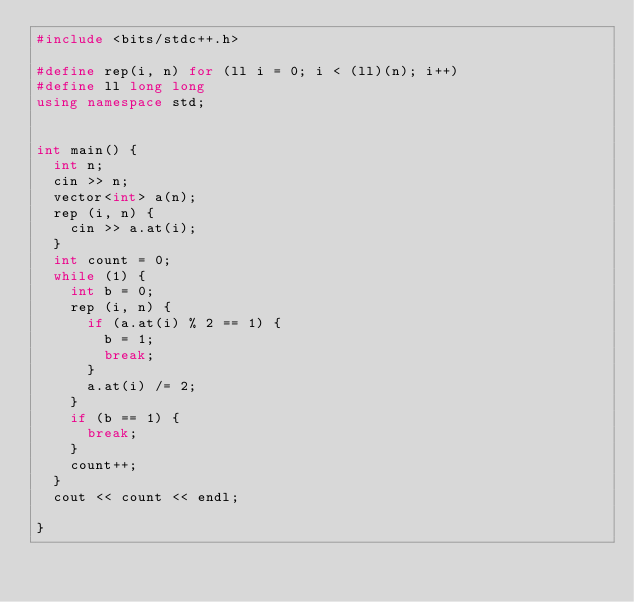<code> <loc_0><loc_0><loc_500><loc_500><_C++_>#include <bits/stdc++.h>

#define rep(i, n) for (ll i = 0; i < (ll)(n); i++)
#define ll long long
using namespace std;


int main() {
  int n;
  cin >> n;
  vector<int> a(n);
  rep (i, n) {
    cin >> a.at(i);
  }
  int count = 0;
  while (1) {
    int b = 0;
    rep (i, n) {
      if (a.at(i) % 2 == 1) {
        b = 1;
        break;
      }
      a.at(i) /= 2;
    }
    if (b == 1) {
      break;
    }
    count++;
  }
  cout << count << endl;

}

</code> 